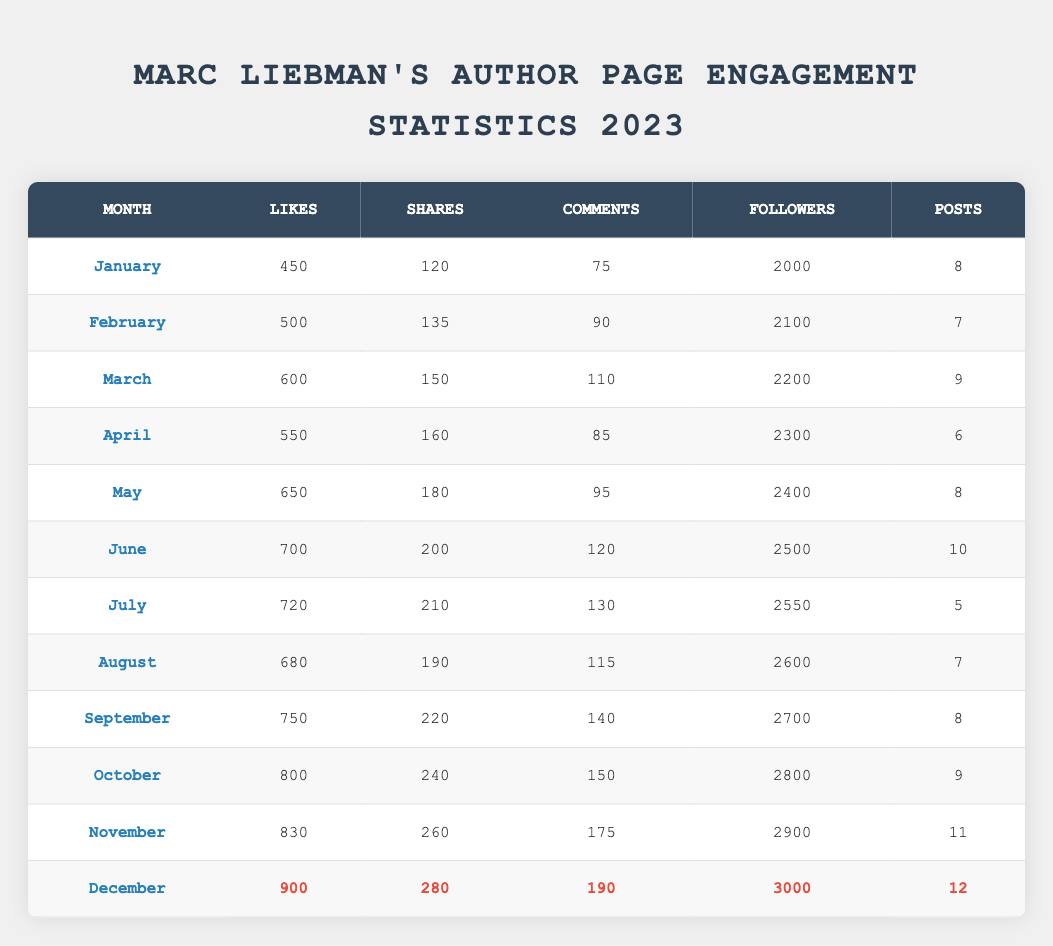What is the total number of likes received in December? In December, the table shows 900 likes. Therefore, the total number of likes received in December is directly stated in the table.
Answer: 900 Which month had the highest number of shares? By looking at the shares column, December has the highest number of shares at 280. Therefore, December is the month with the highest shares.
Answer: December What was the average number of comments across all months? To find the average, first sum the number of comments: 75 + 90 + 110 + 85 + 95 + 120 + 130 + 115 + 140 + 150 + 175 + 190 = 1,310. There are 12 months, so the average is 1,310 / 12 ≈ 109.17.
Answer: 109.17 Did the number of posts in March exceed that in January? In the table, the number of posts in March is 9, while in January it is 8. Since 9 is greater than 8, it confirms that March had more posts than January.
Answer: Yes What is the percentage increase in followers from January to March? The followers in January were 2000 and in March they were 2200. To calculate the percentage increase, use the formula: ((2200 - 2000) / 2000) * 100 = (200 / 2000) * 100 = 10%. Thus, there was a 10% increase in followers from January to March.
Answer: 10% What is the difference between the number of likes in November and the number of likes in July? The number of likes in November is 830, and in July it is 720. The difference is 830 - 720 = 110. Therefore, the difference in likes between November and July is 110.
Answer: 110 Which month has the least number of posts? From the table, July has the least number of posts with only 5. Other months have either 6, 7, 8, 9, 10, 11, or 12 posts. Thus, the month with the least posts is July.
Answer: July How many total shares were recorded from January to June? To find the total shares from January to June, add the shares for each month: 120 + 135 + 150 + 160 + 180 + 200 = 1,045. Therefore, the total shares from January to June is 1,045.
Answer: 1,045 What month saw a drop in likes compared to the previous month? Comparing the likes from month to month, we see that August saw a drop in likes, going from 720 in July to 680 in August. Thus, the month that experienced a drop in likes was August.
Answer: August 